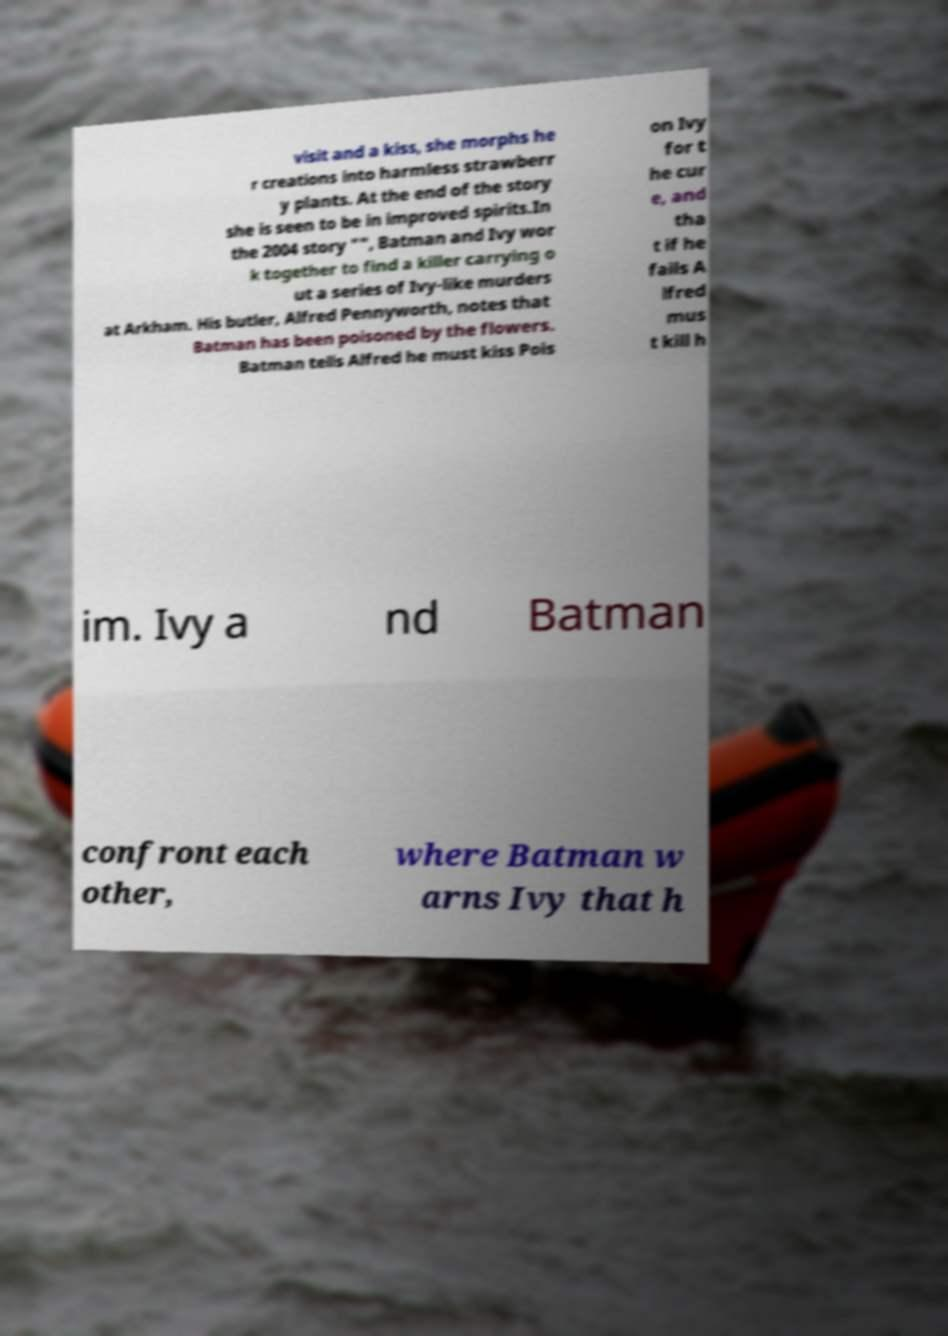Can you read and provide the text displayed in the image?This photo seems to have some interesting text. Can you extract and type it out for me? visit and a kiss, she morphs he r creations into harmless strawberr y plants. At the end of the story she is seen to be in improved spirits.In the 2004 story "", Batman and Ivy wor k together to find a killer carrying o ut a series of Ivy-like murders at Arkham. His butler, Alfred Pennyworth, notes that Batman has been poisoned by the flowers. Batman tells Alfred he must kiss Pois on Ivy for t he cur e, and tha t if he fails A lfred mus t kill h im. Ivy a nd Batman confront each other, where Batman w arns Ivy that h 